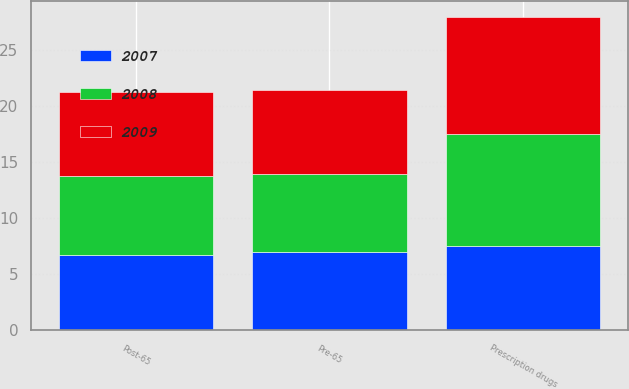<chart> <loc_0><loc_0><loc_500><loc_500><stacked_bar_chart><ecel><fcel>Pre-65<fcel>Post-65<fcel>Prescription drugs<nl><fcel>2007<fcel>7<fcel>6.75<fcel>7.5<nl><fcel>2008<fcel>7<fcel>7<fcel>10<nl><fcel>2009<fcel>7.5<fcel>7.5<fcel>10.5<nl></chart> 